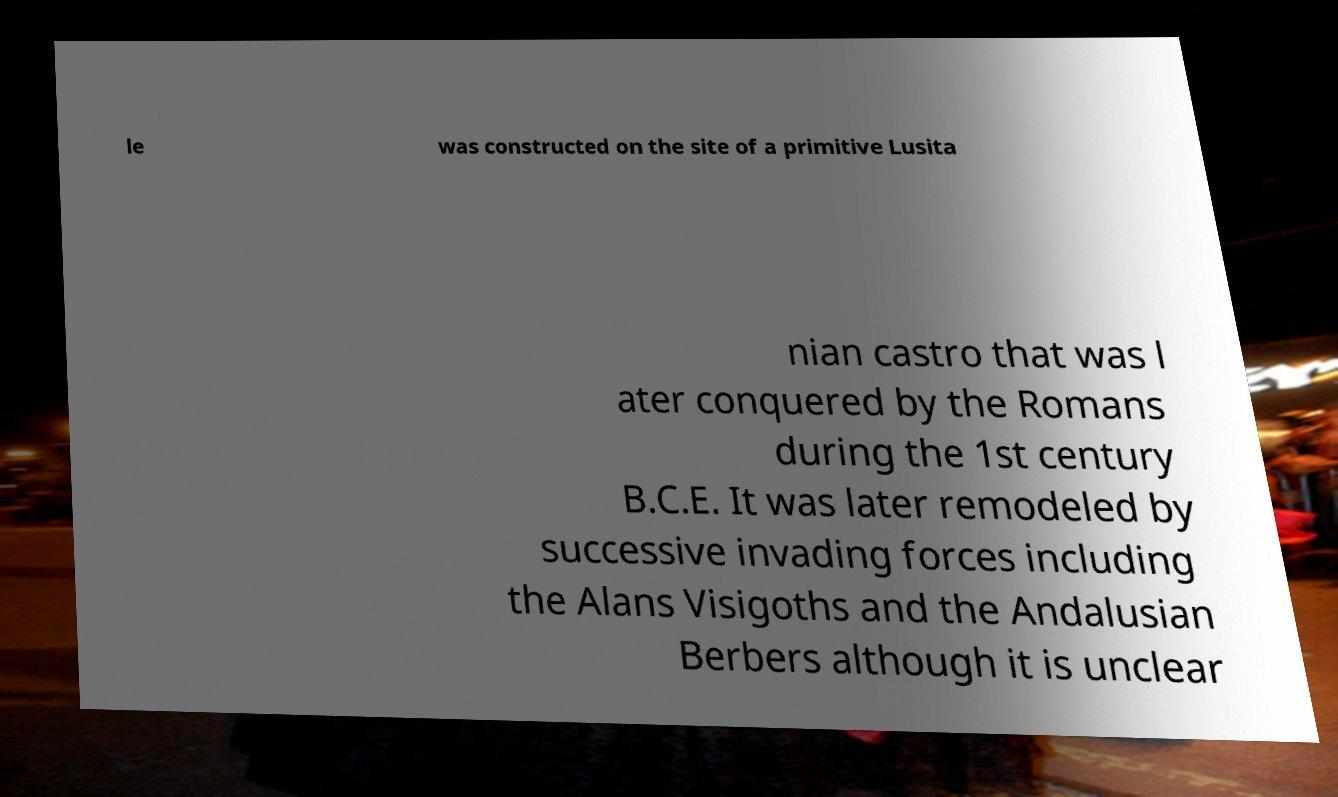There's text embedded in this image that I need extracted. Can you transcribe it verbatim? le was constructed on the site of a primitive Lusita nian castro that was l ater conquered by the Romans during the 1st century B.C.E. It was later remodeled by successive invading forces including the Alans Visigoths and the Andalusian Berbers although it is unclear 